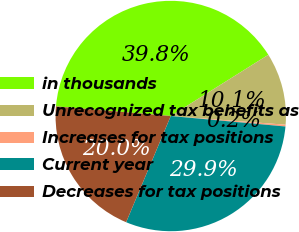Convert chart. <chart><loc_0><loc_0><loc_500><loc_500><pie_chart><fcel>in thousands<fcel>Unrecognized tax benefits as<fcel>Increases for tax positions<fcel>Current year<fcel>Decreases for tax positions<nl><fcel>39.75%<fcel>10.12%<fcel>0.25%<fcel>29.88%<fcel>20.0%<nl></chart> 